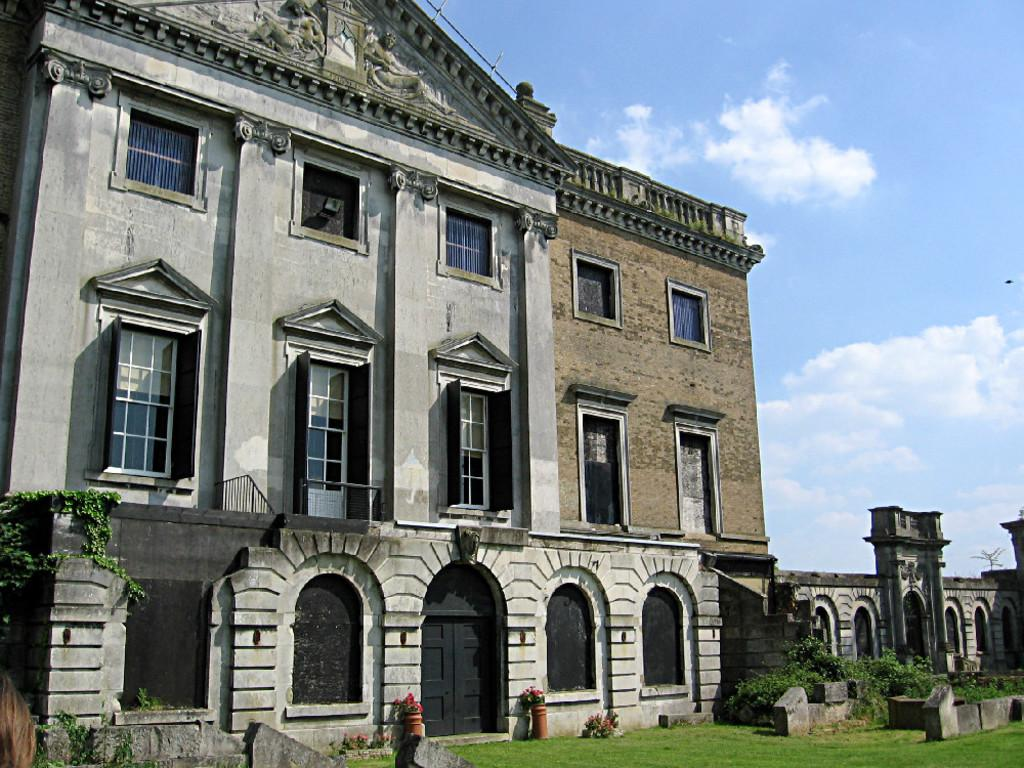What type of structure is in the image? There is an old building in the image. What architectural features can be seen on the building? The building has windows and an arch door at the front bottom side. Do the windows on the arch door have any unique characteristics? Yes, the windows on the arch door are also visible. Where can the alley with dolls be found in the image? There is no alley or dolls present in the image; it only features an old building with windows and an arch door. What type of advertisement is displayed on the building in the image? There is no advertisement present on the building in the image; it only features an old building with windows and an arch door. 